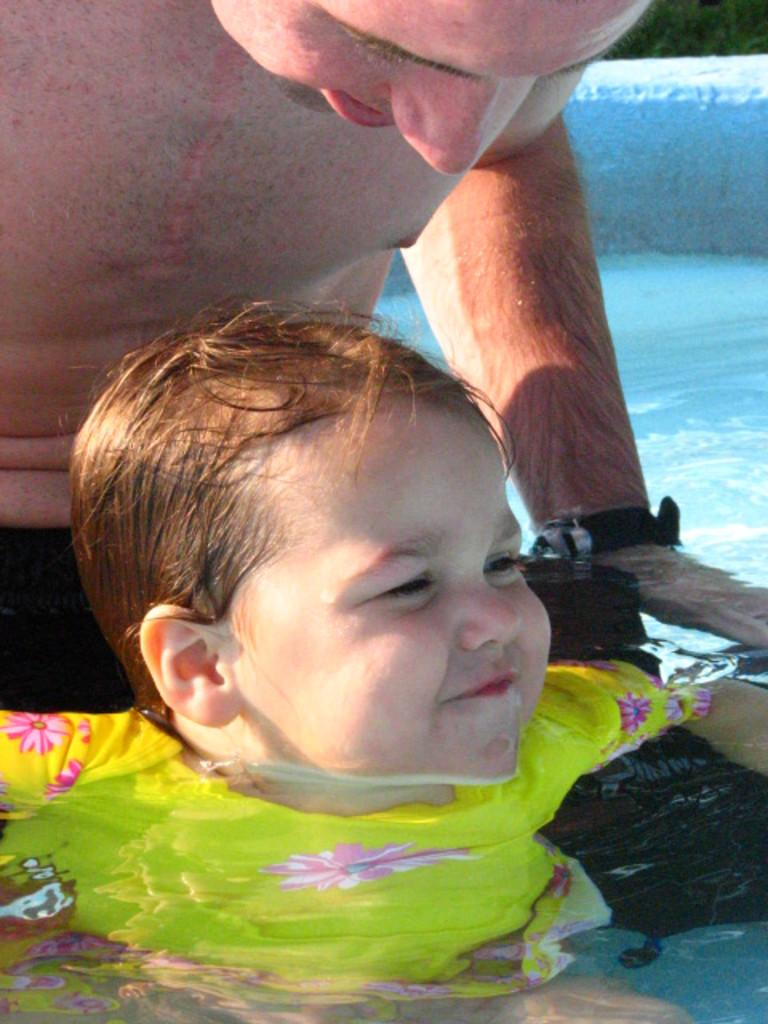Who is present in the image with the baby? There is a man in the image with the baby. Where are the baby and the man located in the image? Both the baby and the man are in a pool. What type of tax can be seen being paid in the image? There is no tax being paid in the image; it features a baby and a man in a pool. What color is the balloon floating above the baby in the image? There is no balloon present in the image. 